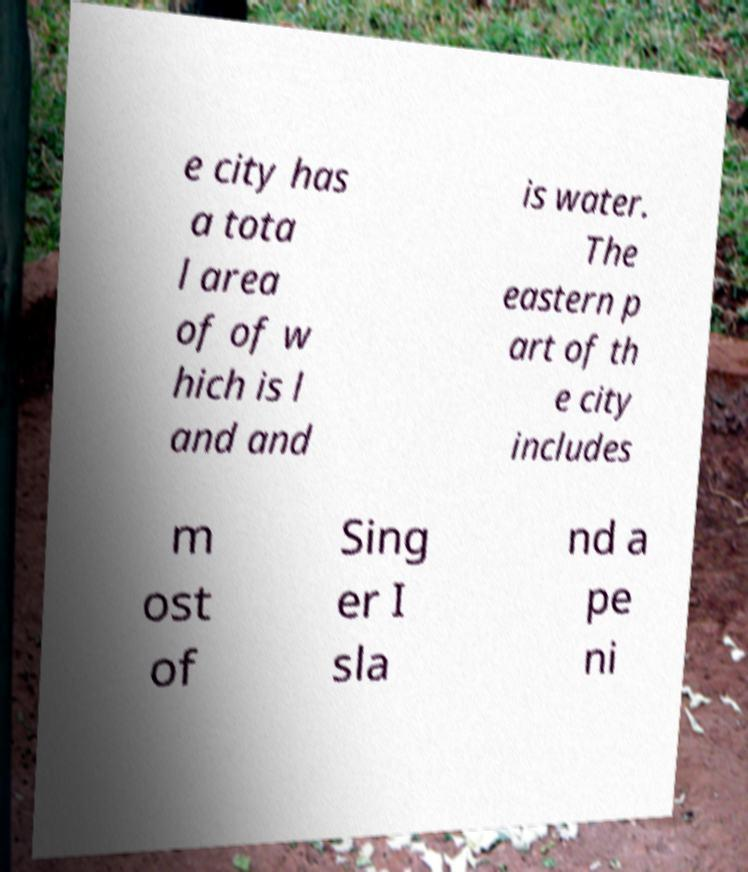Please identify and transcribe the text found in this image. e city has a tota l area of of w hich is l and and is water. The eastern p art of th e city includes m ost of Sing er I sla nd a pe ni 